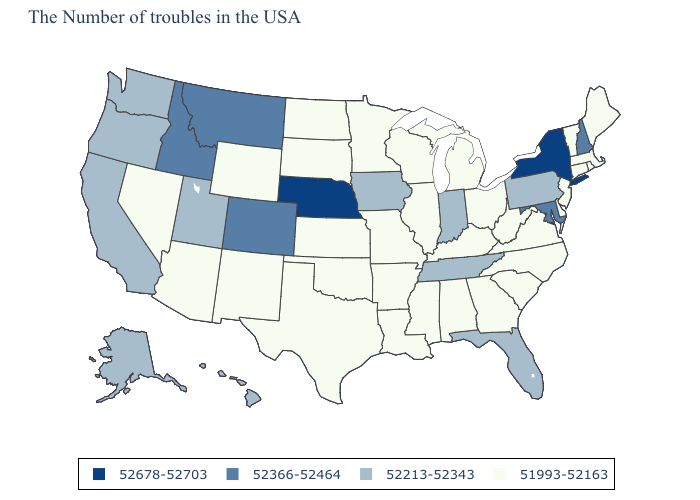Does New York have the lowest value in the Northeast?
Quick response, please. No. What is the value of Iowa?
Be succinct. 52213-52343. How many symbols are there in the legend?
Concise answer only. 4. Name the states that have a value in the range 52366-52464?
Be succinct. New Hampshire, Maryland, Colorado, Montana, Idaho. What is the value of Wisconsin?
Answer briefly. 51993-52163. What is the value of Minnesota?
Write a very short answer. 51993-52163. What is the highest value in the South ?
Quick response, please. 52366-52464. What is the lowest value in the USA?
Write a very short answer. 51993-52163. Does Ohio have the same value as Alaska?
Keep it brief. No. What is the highest value in the West ?
Keep it brief. 52366-52464. Which states have the lowest value in the West?
Quick response, please. Wyoming, New Mexico, Arizona, Nevada. Name the states that have a value in the range 52366-52464?
Answer briefly. New Hampshire, Maryland, Colorado, Montana, Idaho. Among the states that border Missouri , does Kentucky have the lowest value?
Write a very short answer. Yes. Name the states that have a value in the range 51993-52163?
Be succinct. Maine, Massachusetts, Rhode Island, Vermont, Connecticut, New Jersey, Delaware, Virginia, North Carolina, South Carolina, West Virginia, Ohio, Georgia, Michigan, Kentucky, Alabama, Wisconsin, Illinois, Mississippi, Louisiana, Missouri, Arkansas, Minnesota, Kansas, Oklahoma, Texas, South Dakota, North Dakota, Wyoming, New Mexico, Arizona, Nevada. 